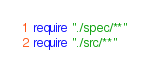<code> <loc_0><loc_0><loc_500><loc_500><_Crystal_>require "./spec/**"
require "./src/**"
</code> 